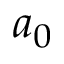Convert formula to latex. <formula><loc_0><loc_0><loc_500><loc_500>a _ { 0 }</formula> 